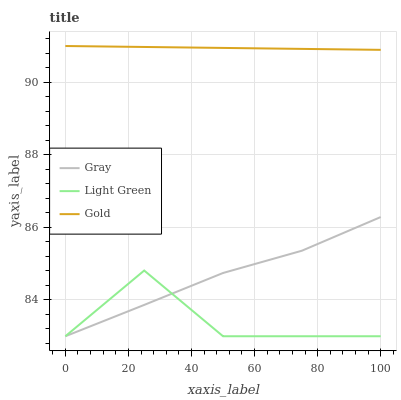Does Light Green have the minimum area under the curve?
Answer yes or no. Yes. Does Gold have the maximum area under the curve?
Answer yes or no. Yes. Does Gold have the minimum area under the curve?
Answer yes or no. No. Does Light Green have the maximum area under the curve?
Answer yes or no. No. Is Gold the smoothest?
Answer yes or no. Yes. Is Light Green the roughest?
Answer yes or no. Yes. Is Light Green the smoothest?
Answer yes or no. No. Is Gold the roughest?
Answer yes or no. No. Does Gray have the lowest value?
Answer yes or no. Yes. Does Gold have the lowest value?
Answer yes or no. No. Does Gold have the highest value?
Answer yes or no. Yes. Does Light Green have the highest value?
Answer yes or no. No. Is Light Green less than Gold?
Answer yes or no. Yes. Is Gold greater than Gray?
Answer yes or no. Yes. Does Light Green intersect Gray?
Answer yes or no. Yes. Is Light Green less than Gray?
Answer yes or no. No. Is Light Green greater than Gray?
Answer yes or no. No. Does Light Green intersect Gold?
Answer yes or no. No. 